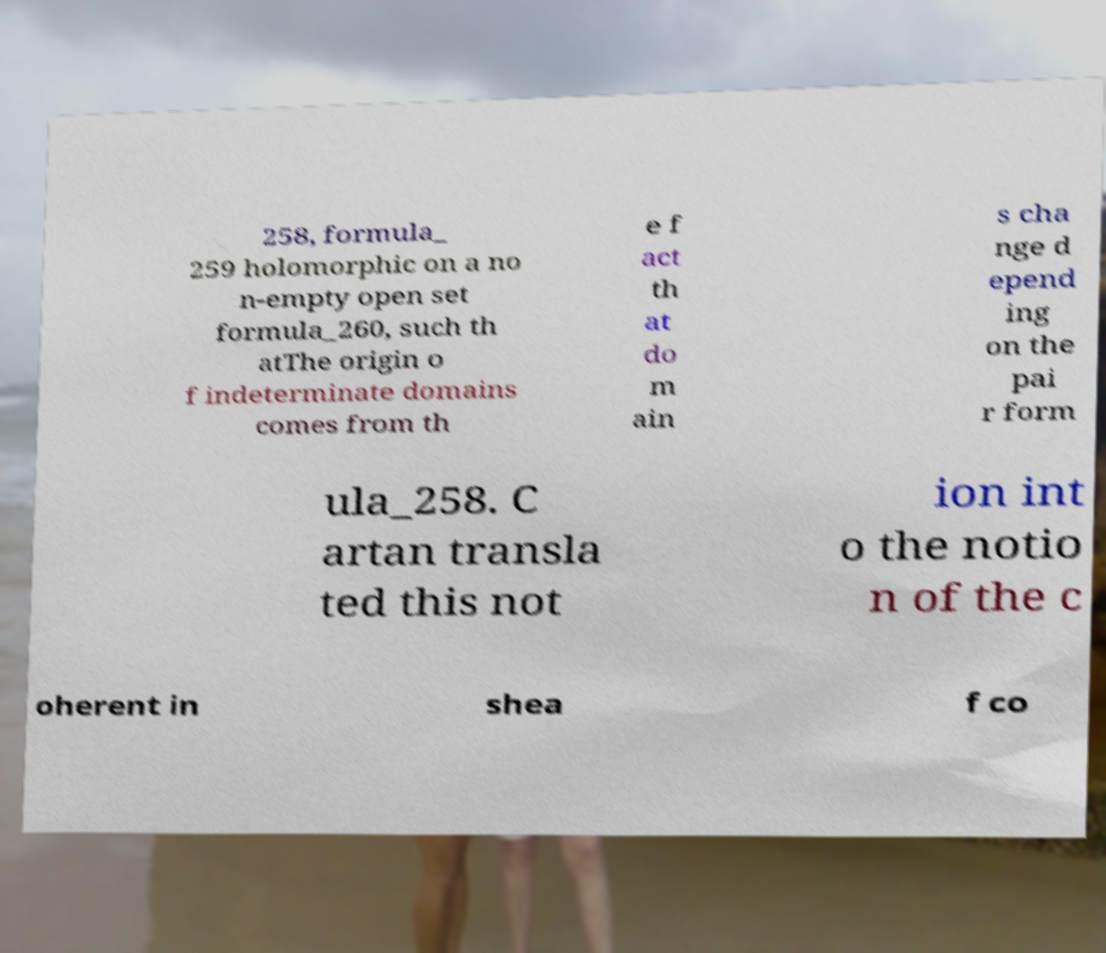For documentation purposes, I need the text within this image transcribed. Could you provide that? 258, formula_ 259 holomorphic on a no n-empty open set formula_260, such th atThe origin o f indeterminate domains comes from th e f act th at do m ain s cha nge d epend ing on the pai r form ula_258. C artan transla ted this not ion int o the notio n of the c oherent in shea f co 